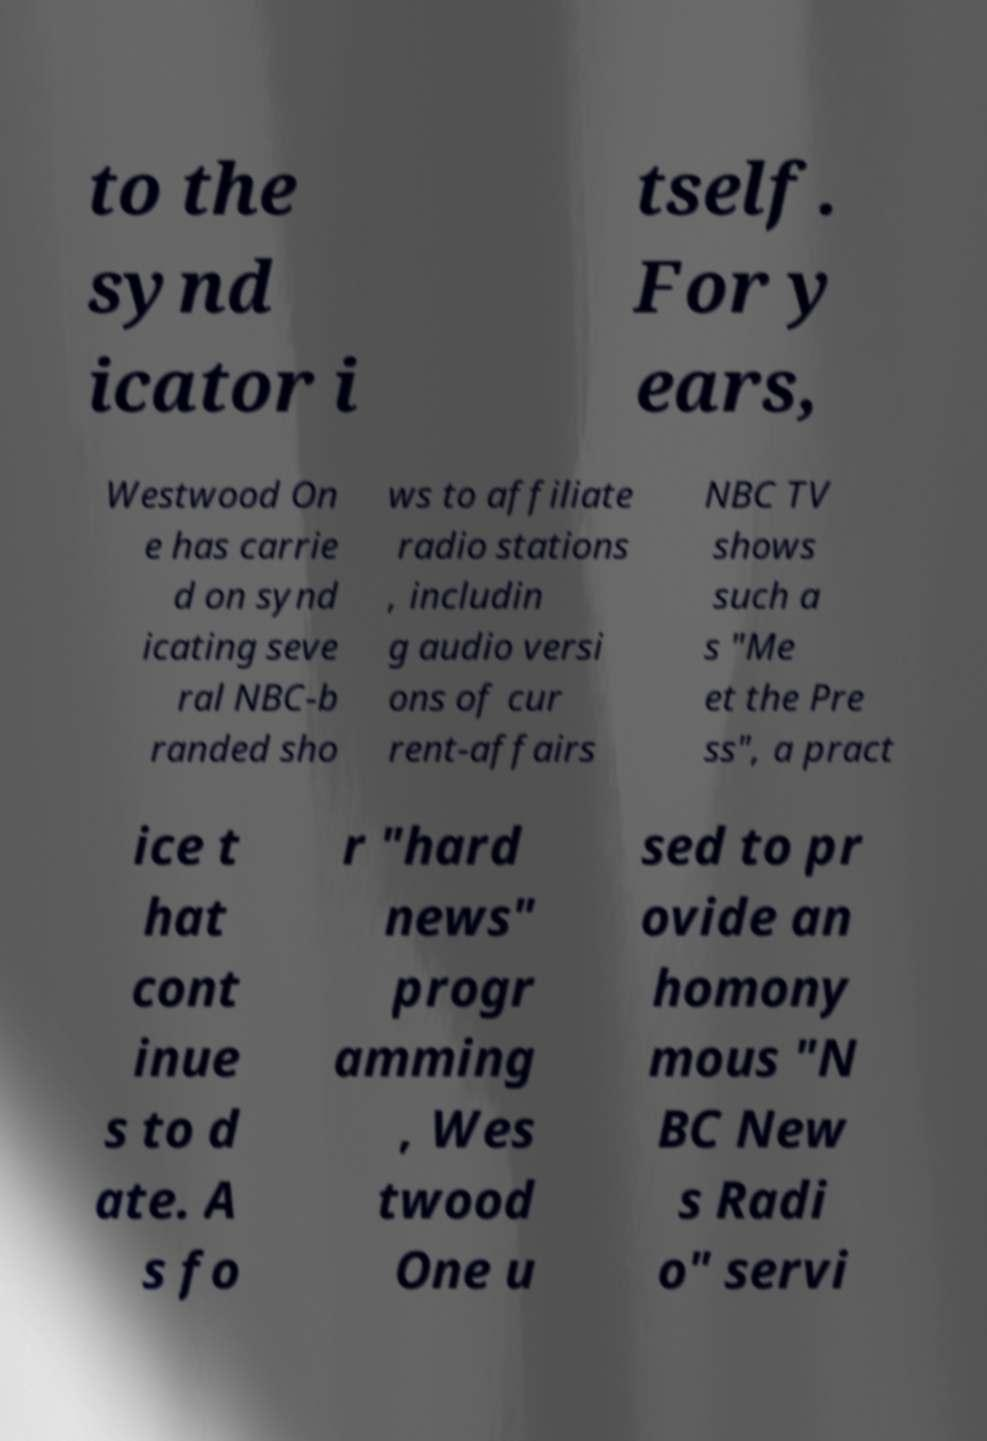I need the written content from this picture converted into text. Can you do that? to the synd icator i tself. For y ears, Westwood On e has carrie d on synd icating seve ral NBC-b randed sho ws to affiliate radio stations , includin g audio versi ons of cur rent-affairs NBC TV shows such a s "Me et the Pre ss", a pract ice t hat cont inue s to d ate. A s fo r "hard news" progr amming , Wes twood One u sed to pr ovide an homony mous "N BC New s Radi o" servi 